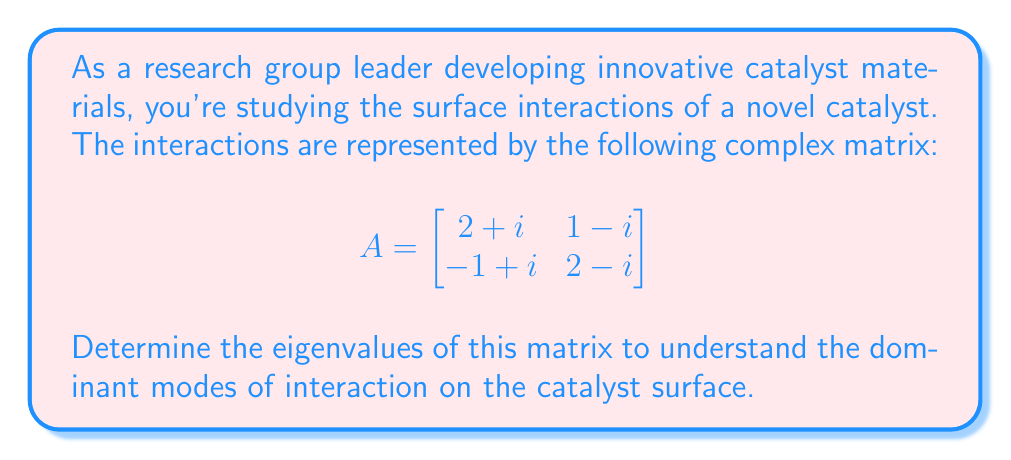Teach me how to tackle this problem. To find the eigenvalues of the complex matrix A, we need to solve the characteristic equation:

$$\det(A - \lambda I) = 0$$

Where $I$ is the 2x2 identity matrix and $\lambda$ represents the eigenvalues.

Step 1: Set up the characteristic equation
$$\begin{vmatrix}
(2+i)-\lambda & 1-i \\
-1+i & (2-i)-\lambda
\end{vmatrix} = 0$$

Step 2: Expand the determinant
$((2+i)-\lambda)((2-i)-\lambda) - (1-i)(-1+i) = 0$

Step 3: Simplify
$(2+i-\lambda)(2-i-\lambda) - (1+1) = 0$
$(4-i^2-2\lambda+i\lambda-i\lambda+\lambda^2) - 2 = 0$
$(5+\lambda^2-2\lambda) - 2 = 0$ (since $i^2 = -1$)

Step 4: Rearrange to standard form
$\lambda^2 - 2\lambda + 3 = 0$

Step 5: Solve the quadratic equation using the quadratic formula
$\lambda = \frac{-b \pm \sqrt{b^2-4ac}}{2a}$

Where $a=1$, $b=-2$, and $c=3$

$\lambda = \frac{2 \pm \sqrt{4-12}}{2} = \frac{2 \pm \sqrt{-8}}{2} = \frac{2 \pm 2\sqrt{2}i}{2}$

Step 6: Simplify the results
$\lambda_1 = 1 + i\sqrt{2}$
$\lambda_2 = 1 - i\sqrt{2}$

These eigenvalues represent the principal axes of interaction on the catalyst surface, with the real part indicating the strength of the interaction and the imaginary part representing the oscillatory nature of the interaction.
Answer: The eigenvalues of the given complex matrix are:
$\lambda_1 = 1 + i\sqrt{2}$ and $\lambda_2 = 1 - i\sqrt{2}$ 